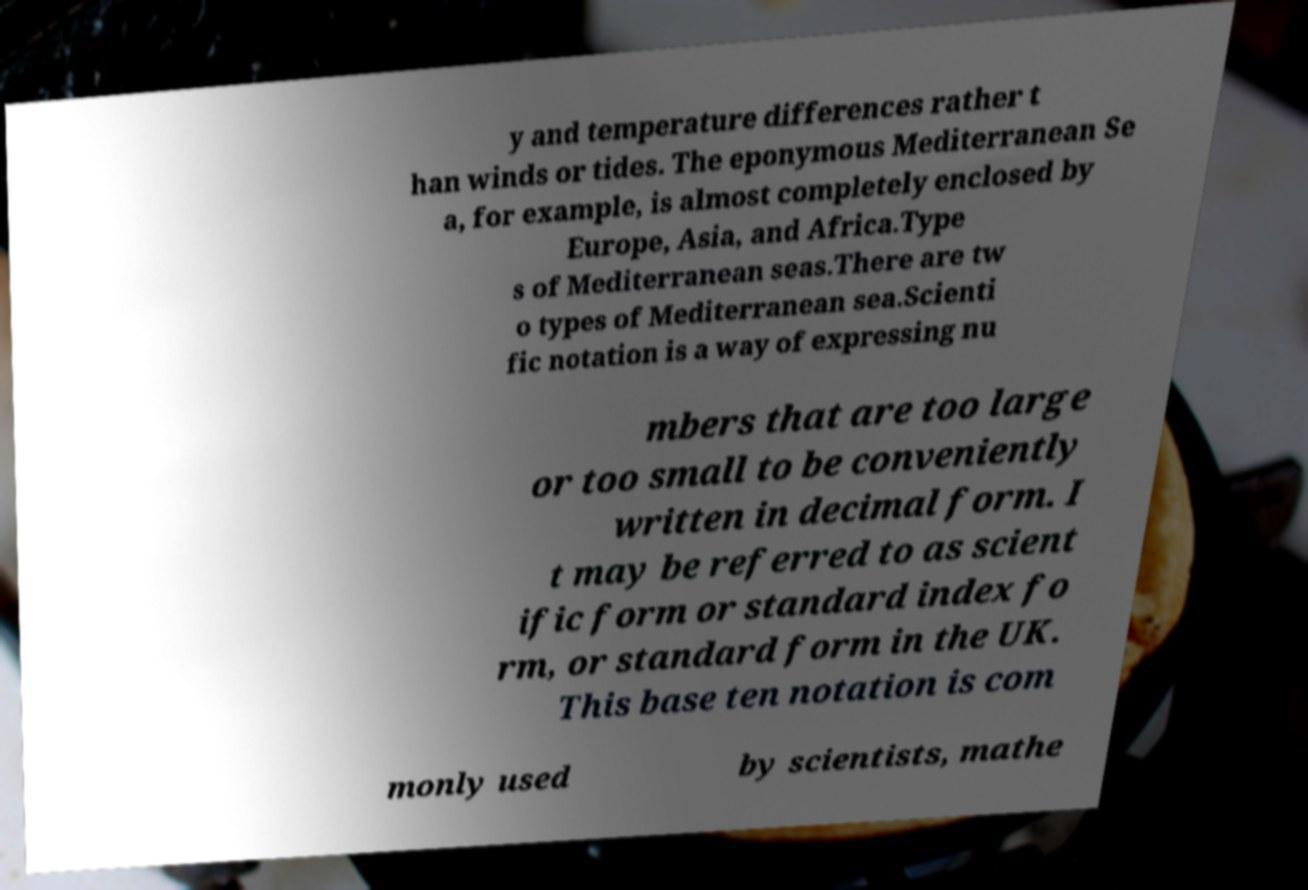Can you read and provide the text displayed in the image?This photo seems to have some interesting text. Can you extract and type it out for me? y and temperature differences rather t han winds or tides. The eponymous Mediterranean Se a, for example, is almost completely enclosed by Europe, Asia, and Africa.Type s of Mediterranean seas.There are tw o types of Mediterranean sea.Scienti fic notation is a way of expressing nu mbers that are too large or too small to be conveniently written in decimal form. I t may be referred to as scient ific form or standard index fo rm, or standard form in the UK. This base ten notation is com monly used by scientists, mathe 